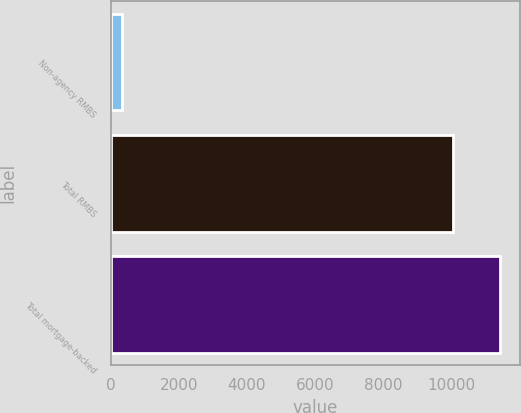Convert chart. <chart><loc_0><loc_0><loc_500><loc_500><bar_chart><fcel>Non-agency RMBS<fcel>Total RMBS<fcel>Total mortgage-backed<nl><fcel>337<fcel>10037<fcel>11423<nl></chart> 